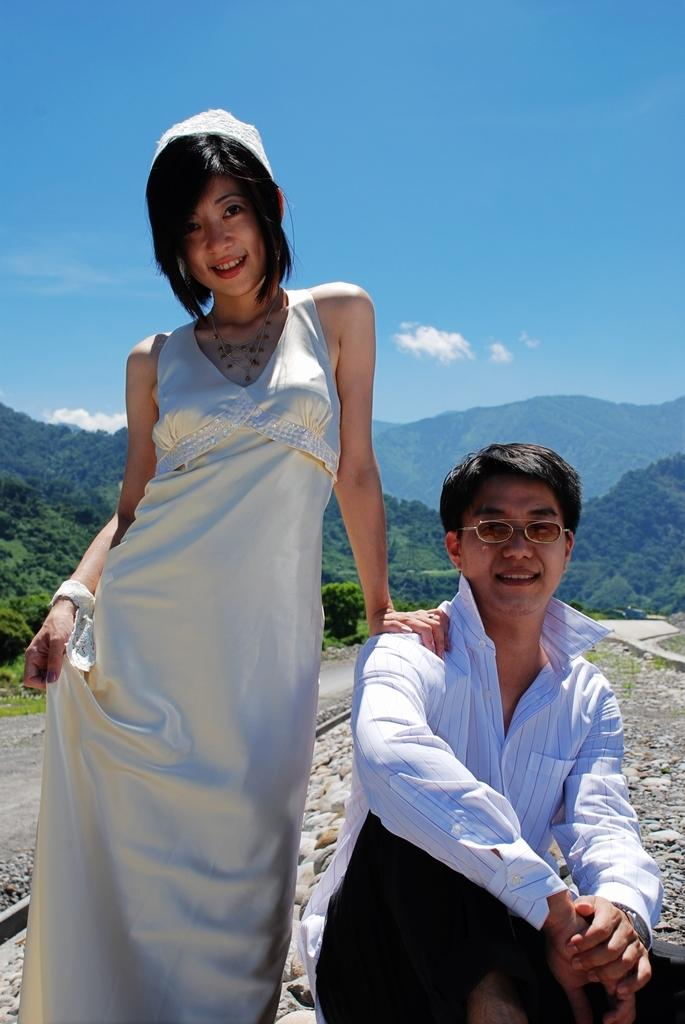How many people are in the image? There are two persons in the image. What is the man doing in the image? The man is sitting in the image. What is the woman doing in the image? The woman is standing beside the man. What can be seen in the background of the image? There are trees, a mountain, and the sky visible in the background of the image. What type of stew is being prepared by the queen in the image? There is no queen or stew present in the image. Can you describe how the woman is touching the man in the image? The image does not show any physical contact between the man and the woman, so it is not possible to describe how they are touching. 